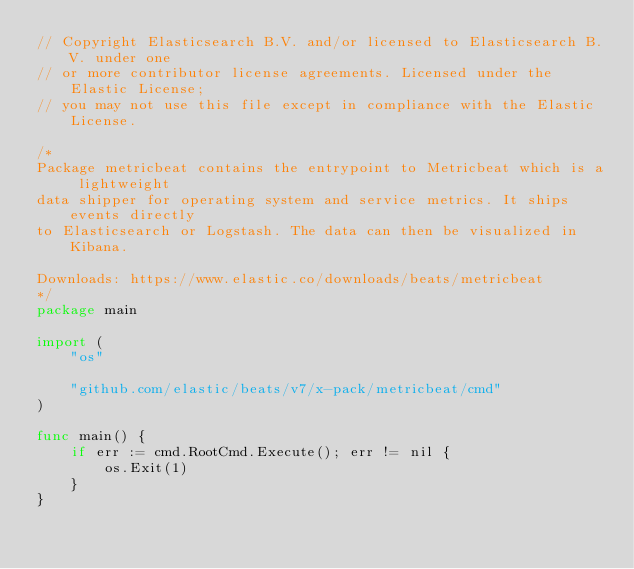Convert code to text. <code><loc_0><loc_0><loc_500><loc_500><_Go_>// Copyright Elasticsearch B.V. and/or licensed to Elasticsearch B.V. under one
// or more contributor license agreements. Licensed under the Elastic License;
// you may not use this file except in compliance with the Elastic License.

/*
Package metricbeat contains the entrypoint to Metricbeat which is a lightweight
data shipper for operating system and service metrics. It ships events directly
to Elasticsearch or Logstash. The data can then be visualized in Kibana.

Downloads: https://www.elastic.co/downloads/beats/metricbeat
*/
package main

import (
	"os"

	"github.com/elastic/beats/v7/x-pack/metricbeat/cmd"
)

func main() {
	if err := cmd.RootCmd.Execute(); err != nil {
		os.Exit(1)
	}
}
</code> 